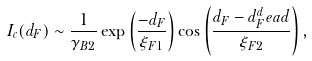<formula> <loc_0><loc_0><loc_500><loc_500>I _ { c } ( d _ { F } ) \sim \frac { 1 } { \gamma _ { B 2 } } \exp \left ( \frac { - d _ { F } } { \xi _ { F 1 } } \right ) \cos \left ( \frac { d _ { F } - d _ { F } ^ { d } e a d } { \xi _ { F 2 } } \right ) ,</formula> 